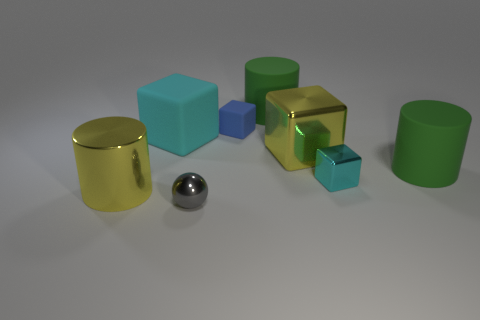How many cyan blocks must be subtracted to get 1 cyan blocks? 1 Subtract all metal cylinders. How many cylinders are left? 2 Subtract all yellow blocks. How many blocks are left? 3 Subtract all spheres. How many objects are left? 7 Subtract 1 spheres. How many spheres are left? 0 Add 5 small cyan things. How many small cyan things exist? 6 Add 2 small yellow shiny cylinders. How many objects exist? 10 Subtract 1 yellow cylinders. How many objects are left? 7 Subtract all purple cylinders. Subtract all cyan balls. How many cylinders are left? 3 Subtract all red balls. How many green blocks are left? 0 